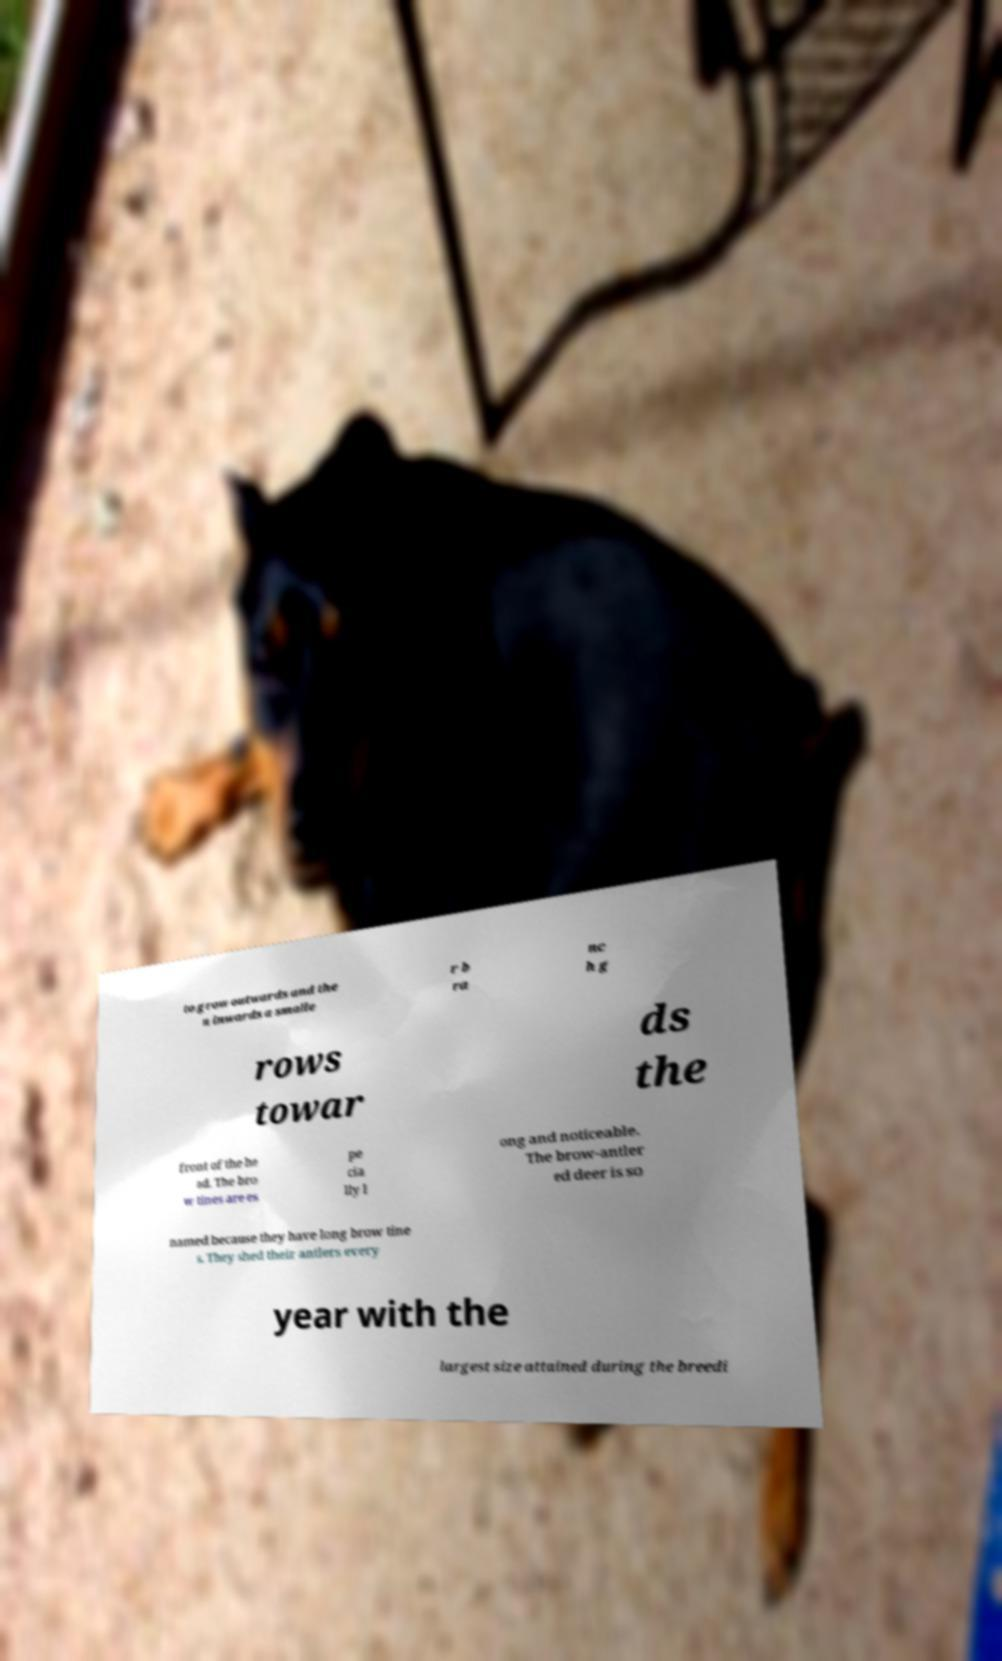I need the written content from this picture converted into text. Can you do that? to grow outwards and the n inwards a smalle r b ra nc h g rows towar ds the front of the he ad. The bro w tines are es pe cia lly l ong and noticeable. The brow-antler ed deer is so named because they have long brow tine s. They shed their antlers every year with the largest size attained during the breedi 